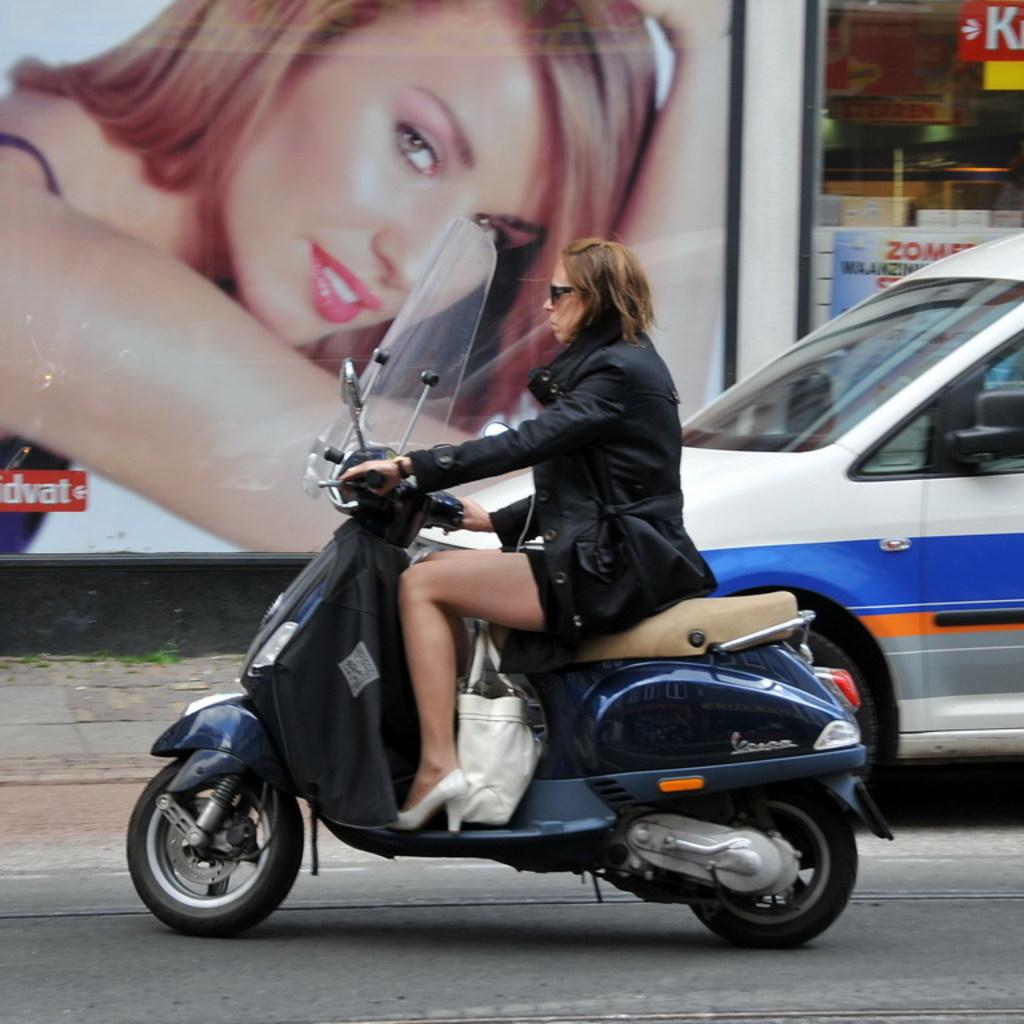What type of vehicle is present in the image? There is a car in the image. What is the woman doing in the image? The woman is riding a motorbike in the image. Where are the car and motorbike located? The car and motorbike are on a road in the image. What can be seen in the background of the image? There is a hoarding and a glass door with posters in the background of the image. What type of blood is visible on the car in the image? There is no blood visible on the car in the image. What type of quilt is being used as a seat cover on the motorbike? There is no quilt present on the motorbike in the image. 